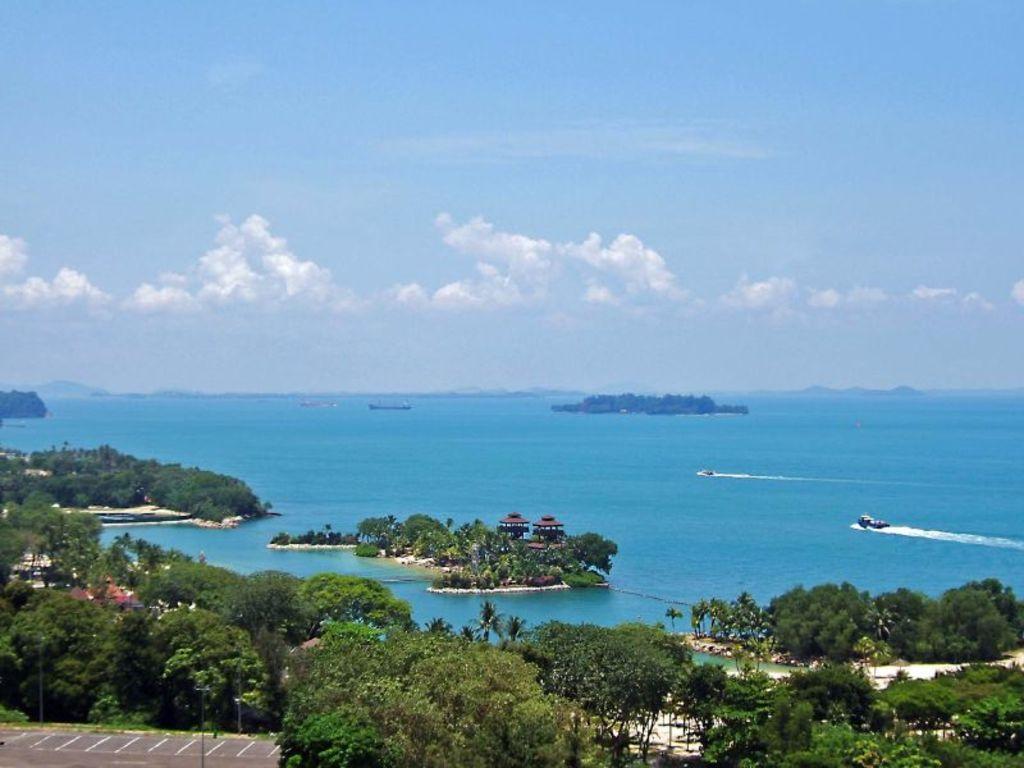In one or two sentences, can you explain what this image depicts? In this image there are trees, lamp posts, parking lot, houses, islands in the water and there are boats in the sea, at the top of the image there are clouds in the sky. 